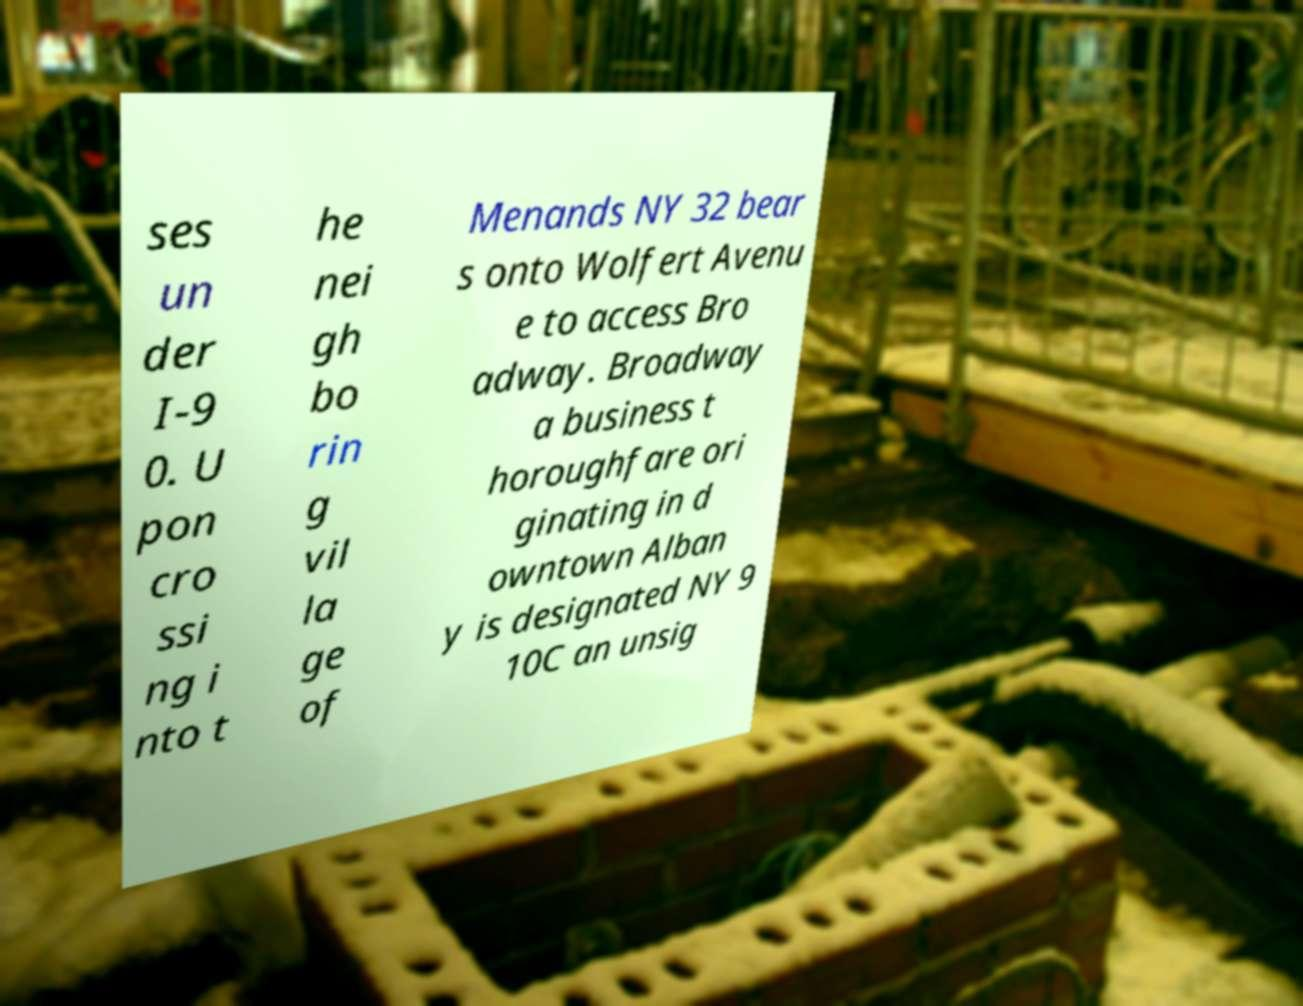Please identify and transcribe the text found in this image. ses un der I-9 0. U pon cro ssi ng i nto t he nei gh bo rin g vil la ge of Menands NY 32 bear s onto Wolfert Avenu e to access Bro adway. Broadway a business t horoughfare ori ginating in d owntown Alban y is designated NY 9 10C an unsig 